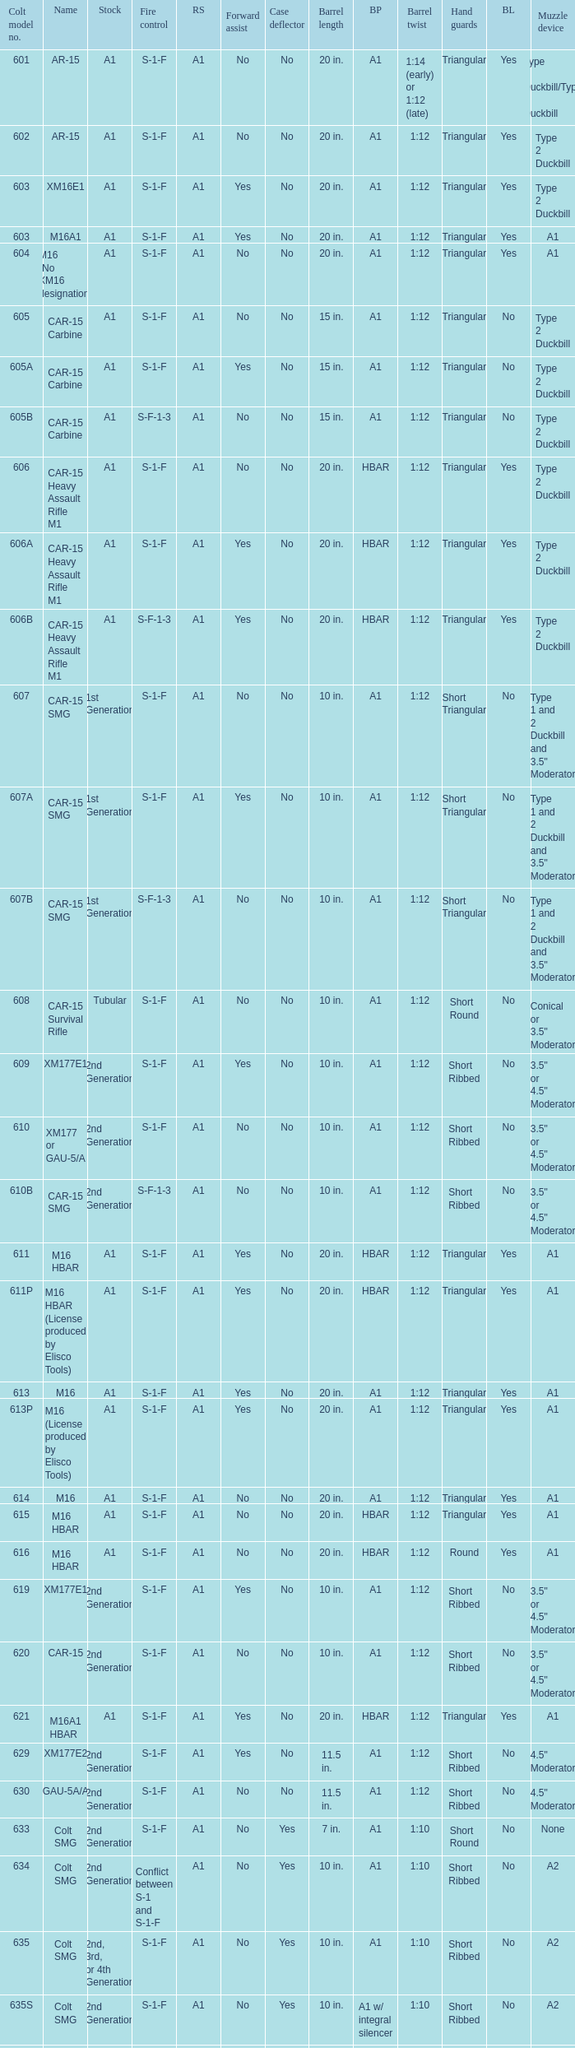What's the type of muzzle devices on the models with round hand guards? A1. 